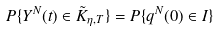Convert formula to latex. <formula><loc_0><loc_0><loc_500><loc_500>P \{ Y ^ { N } ( t ) \in \tilde { K } _ { \eta , T } \} = P \{ q ^ { N } ( 0 ) \in I \}</formula> 